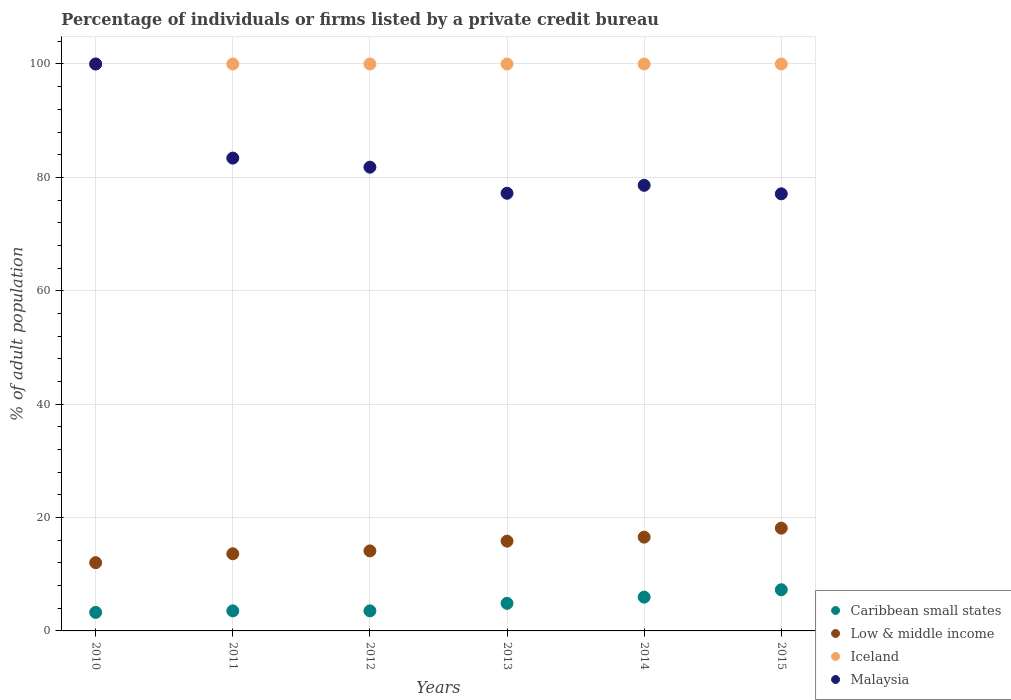How many different coloured dotlines are there?
Your response must be concise. 4. Is the number of dotlines equal to the number of legend labels?
Make the answer very short. Yes. What is the percentage of population listed by a private credit bureau in Iceland in 2011?
Ensure brevity in your answer.  100. Across all years, what is the maximum percentage of population listed by a private credit bureau in Low & middle income?
Your response must be concise. 18.13. Across all years, what is the minimum percentage of population listed by a private credit bureau in Iceland?
Provide a short and direct response. 100. What is the total percentage of population listed by a private credit bureau in Iceland in the graph?
Keep it short and to the point. 600. What is the difference between the percentage of population listed by a private credit bureau in Caribbean small states in 2013 and that in 2015?
Offer a terse response. -2.4. What is the difference between the percentage of population listed by a private credit bureau in Low & middle income in 2013 and the percentage of population listed by a private credit bureau in Caribbean small states in 2014?
Provide a short and direct response. 9.87. What is the average percentage of population listed by a private credit bureau in Malaysia per year?
Ensure brevity in your answer.  83.02. In the year 2015, what is the difference between the percentage of population listed by a private credit bureau in Malaysia and percentage of population listed by a private credit bureau in Low & middle income?
Offer a terse response. 58.97. In how many years, is the percentage of population listed by a private credit bureau in Iceland greater than 68 %?
Provide a succinct answer. 6. What is the ratio of the percentage of population listed by a private credit bureau in Low & middle income in 2010 to that in 2011?
Your response must be concise. 0.88. Is the percentage of population listed by a private credit bureau in Low & middle income in 2012 less than that in 2014?
Your response must be concise. Yes. Is the difference between the percentage of population listed by a private credit bureau in Malaysia in 2010 and 2015 greater than the difference between the percentage of population listed by a private credit bureau in Low & middle income in 2010 and 2015?
Offer a terse response. Yes. What is the difference between the highest and the second highest percentage of population listed by a private credit bureau in Low & middle income?
Ensure brevity in your answer.  1.59. What is the difference between the highest and the lowest percentage of population listed by a private credit bureau in Malaysia?
Your answer should be compact. 22.9. In how many years, is the percentage of population listed by a private credit bureau in Low & middle income greater than the average percentage of population listed by a private credit bureau in Low & middle income taken over all years?
Provide a short and direct response. 3. Is the sum of the percentage of population listed by a private credit bureau in Malaysia in 2010 and 2012 greater than the maximum percentage of population listed by a private credit bureau in Low & middle income across all years?
Your response must be concise. Yes. Is it the case that in every year, the sum of the percentage of population listed by a private credit bureau in Malaysia and percentage of population listed by a private credit bureau in Iceland  is greater than the sum of percentage of population listed by a private credit bureau in Caribbean small states and percentage of population listed by a private credit bureau in Low & middle income?
Your answer should be very brief. Yes. Does the percentage of population listed by a private credit bureau in Caribbean small states monotonically increase over the years?
Provide a succinct answer. No. Is the percentage of population listed by a private credit bureau in Low & middle income strictly greater than the percentage of population listed by a private credit bureau in Malaysia over the years?
Offer a terse response. No. How many dotlines are there?
Provide a short and direct response. 4. What is the difference between two consecutive major ticks on the Y-axis?
Keep it short and to the point. 20. Are the values on the major ticks of Y-axis written in scientific E-notation?
Ensure brevity in your answer.  No. Does the graph contain any zero values?
Ensure brevity in your answer.  No. Where does the legend appear in the graph?
Your response must be concise. Bottom right. How are the legend labels stacked?
Your answer should be compact. Vertical. What is the title of the graph?
Your response must be concise. Percentage of individuals or firms listed by a private credit bureau. Does "Fragile and conflict affected situations" appear as one of the legend labels in the graph?
Provide a succinct answer. No. What is the label or title of the X-axis?
Your answer should be compact. Years. What is the label or title of the Y-axis?
Make the answer very short. % of adult population. What is the % of adult population of Caribbean small states in 2010?
Provide a short and direct response. 3.27. What is the % of adult population in Low & middle income in 2010?
Your answer should be compact. 12.04. What is the % of adult population in Iceland in 2010?
Keep it short and to the point. 100. What is the % of adult population in Malaysia in 2010?
Keep it short and to the point. 100. What is the % of adult population of Caribbean small states in 2011?
Provide a succinct answer. 3.54. What is the % of adult population in Low & middle income in 2011?
Give a very brief answer. 13.61. What is the % of adult population in Iceland in 2011?
Your answer should be very brief. 100. What is the % of adult population of Malaysia in 2011?
Provide a succinct answer. 83.4. What is the % of adult population in Caribbean small states in 2012?
Offer a terse response. 3.54. What is the % of adult population of Low & middle income in 2012?
Make the answer very short. 14.12. What is the % of adult population in Iceland in 2012?
Your answer should be compact. 100. What is the % of adult population in Malaysia in 2012?
Make the answer very short. 81.8. What is the % of adult population in Caribbean small states in 2013?
Offer a very short reply. 4.86. What is the % of adult population of Low & middle income in 2013?
Your answer should be very brief. 15.83. What is the % of adult population in Iceland in 2013?
Provide a succinct answer. 100. What is the % of adult population of Malaysia in 2013?
Offer a terse response. 77.2. What is the % of adult population of Caribbean small states in 2014?
Ensure brevity in your answer.  5.96. What is the % of adult population of Low & middle income in 2014?
Offer a terse response. 16.54. What is the % of adult population of Malaysia in 2014?
Make the answer very short. 78.6. What is the % of adult population in Caribbean small states in 2015?
Your response must be concise. 7.26. What is the % of adult population of Low & middle income in 2015?
Provide a succinct answer. 18.13. What is the % of adult population in Malaysia in 2015?
Give a very brief answer. 77.1. Across all years, what is the maximum % of adult population of Caribbean small states?
Keep it short and to the point. 7.26. Across all years, what is the maximum % of adult population in Low & middle income?
Give a very brief answer. 18.13. Across all years, what is the maximum % of adult population of Iceland?
Ensure brevity in your answer.  100. Across all years, what is the minimum % of adult population in Caribbean small states?
Your answer should be very brief. 3.27. Across all years, what is the minimum % of adult population of Low & middle income?
Your response must be concise. 12.04. Across all years, what is the minimum % of adult population in Malaysia?
Your answer should be compact. 77.1. What is the total % of adult population of Caribbean small states in the graph?
Your response must be concise. 28.43. What is the total % of adult population in Low & middle income in the graph?
Provide a succinct answer. 90.27. What is the total % of adult population in Iceland in the graph?
Your answer should be compact. 600. What is the total % of adult population in Malaysia in the graph?
Provide a succinct answer. 498.1. What is the difference between the % of adult population in Caribbean small states in 2010 and that in 2011?
Ensure brevity in your answer.  -0.27. What is the difference between the % of adult population in Low & middle income in 2010 and that in 2011?
Your answer should be very brief. -1.57. What is the difference between the % of adult population of Iceland in 2010 and that in 2011?
Offer a terse response. 0. What is the difference between the % of adult population in Malaysia in 2010 and that in 2011?
Offer a terse response. 16.6. What is the difference between the % of adult population of Caribbean small states in 2010 and that in 2012?
Provide a succinct answer. -0.27. What is the difference between the % of adult population of Low & middle income in 2010 and that in 2012?
Provide a succinct answer. -2.08. What is the difference between the % of adult population of Malaysia in 2010 and that in 2012?
Provide a succinct answer. 18.2. What is the difference between the % of adult population in Caribbean small states in 2010 and that in 2013?
Your answer should be compact. -1.59. What is the difference between the % of adult population in Low & middle income in 2010 and that in 2013?
Your answer should be compact. -3.8. What is the difference between the % of adult population of Malaysia in 2010 and that in 2013?
Make the answer very short. 22.8. What is the difference between the % of adult population of Caribbean small states in 2010 and that in 2014?
Make the answer very short. -2.69. What is the difference between the % of adult population of Low & middle income in 2010 and that in 2014?
Provide a short and direct response. -4.51. What is the difference between the % of adult population in Malaysia in 2010 and that in 2014?
Ensure brevity in your answer.  21.4. What is the difference between the % of adult population of Caribbean small states in 2010 and that in 2015?
Make the answer very short. -3.99. What is the difference between the % of adult population in Low & middle income in 2010 and that in 2015?
Offer a terse response. -6.09. What is the difference between the % of adult population of Iceland in 2010 and that in 2015?
Offer a very short reply. 0. What is the difference between the % of adult population of Malaysia in 2010 and that in 2015?
Provide a short and direct response. 22.9. What is the difference between the % of adult population of Caribbean small states in 2011 and that in 2012?
Ensure brevity in your answer.  0. What is the difference between the % of adult population of Low & middle income in 2011 and that in 2012?
Your answer should be compact. -0.51. What is the difference between the % of adult population of Caribbean small states in 2011 and that in 2013?
Offer a terse response. -1.32. What is the difference between the % of adult population in Low & middle income in 2011 and that in 2013?
Offer a terse response. -2.23. What is the difference between the % of adult population of Caribbean small states in 2011 and that in 2014?
Offer a terse response. -2.42. What is the difference between the % of adult population of Low & middle income in 2011 and that in 2014?
Make the answer very short. -2.93. What is the difference between the % of adult population in Iceland in 2011 and that in 2014?
Provide a short and direct response. 0. What is the difference between the % of adult population of Malaysia in 2011 and that in 2014?
Offer a terse response. 4.8. What is the difference between the % of adult population of Caribbean small states in 2011 and that in 2015?
Offer a very short reply. -3.72. What is the difference between the % of adult population of Low & middle income in 2011 and that in 2015?
Offer a terse response. -4.52. What is the difference between the % of adult population of Iceland in 2011 and that in 2015?
Give a very brief answer. 0. What is the difference between the % of adult population in Caribbean small states in 2012 and that in 2013?
Ensure brevity in your answer.  -1.32. What is the difference between the % of adult population of Low & middle income in 2012 and that in 2013?
Give a very brief answer. -1.72. What is the difference between the % of adult population of Iceland in 2012 and that in 2013?
Provide a short and direct response. 0. What is the difference between the % of adult population of Malaysia in 2012 and that in 2013?
Ensure brevity in your answer.  4.6. What is the difference between the % of adult population of Caribbean small states in 2012 and that in 2014?
Your answer should be compact. -2.42. What is the difference between the % of adult population of Low & middle income in 2012 and that in 2014?
Ensure brevity in your answer.  -2.43. What is the difference between the % of adult population of Malaysia in 2012 and that in 2014?
Keep it short and to the point. 3.2. What is the difference between the % of adult population of Caribbean small states in 2012 and that in 2015?
Make the answer very short. -3.72. What is the difference between the % of adult population of Low & middle income in 2012 and that in 2015?
Provide a short and direct response. -4.01. What is the difference between the % of adult population in Malaysia in 2012 and that in 2015?
Offer a terse response. 4.7. What is the difference between the % of adult population in Low & middle income in 2013 and that in 2014?
Make the answer very short. -0.71. What is the difference between the % of adult population of Malaysia in 2013 and that in 2014?
Ensure brevity in your answer.  -1.4. What is the difference between the % of adult population of Caribbean small states in 2013 and that in 2015?
Offer a terse response. -2.4. What is the difference between the % of adult population in Low & middle income in 2013 and that in 2015?
Make the answer very short. -2.29. What is the difference between the % of adult population of Iceland in 2013 and that in 2015?
Keep it short and to the point. 0. What is the difference between the % of adult population of Low & middle income in 2014 and that in 2015?
Keep it short and to the point. -1.59. What is the difference between the % of adult population in Iceland in 2014 and that in 2015?
Keep it short and to the point. 0. What is the difference between the % of adult population in Malaysia in 2014 and that in 2015?
Offer a terse response. 1.5. What is the difference between the % of adult population of Caribbean small states in 2010 and the % of adult population of Low & middle income in 2011?
Provide a succinct answer. -10.34. What is the difference between the % of adult population in Caribbean small states in 2010 and the % of adult population in Iceland in 2011?
Provide a succinct answer. -96.73. What is the difference between the % of adult population in Caribbean small states in 2010 and the % of adult population in Malaysia in 2011?
Ensure brevity in your answer.  -80.13. What is the difference between the % of adult population in Low & middle income in 2010 and the % of adult population in Iceland in 2011?
Keep it short and to the point. -87.96. What is the difference between the % of adult population of Low & middle income in 2010 and the % of adult population of Malaysia in 2011?
Keep it short and to the point. -71.36. What is the difference between the % of adult population in Caribbean small states in 2010 and the % of adult population in Low & middle income in 2012?
Provide a succinct answer. -10.85. What is the difference between the % of adult population of Caribbean small states in 2010 and the % of adult population of Iceland in 2012?
Give a very brief answer. -96.73. What is the difference between the % of adult population in Caribbean small states in 2010 and the % of adult population in Malaysia in 2012?
Provide a short and direct response. -78.53. What is the difference between the % of adult population of Low & middle income in 2010 and the % of adult population of Iceland in 2012?
Your answer should be compact. -87.96. What is the difference between the % of adult population in Low & middle income in 2010 and the % of adult population in Malaysia in 2012?
Provide a succinct answer. -69.76. What is the difference between the % of adult population of Iceland in 2010 and the % of adult population of Malaysia in 2012?
Provide a short and direct response. 18.2. What is the difference between the % of adult population in Caribbean small states in 2010 and the % of adult population in Low & middle income in 2013?
Provide a short and direct response. -12.57. What is the difference between the % of adult population in Caribbean small states in 2010 and the % of adult population in Iceland in 2013?
Your response must be concise. -96.73. What is the difference between the % of adult population of Caribbean small states in 2010 and the % of adult population of Malaysia in 2013?
Provide a succinct answer. -73.93. What is the difference between the % of adult population in Low & middle income in 2010 and the % of adult population in Iceland in 2013?
Your answer should be very brief. -87.96. What is the difference between the % of adult population of Low & middle income in 2010 and the % of adult population of Malaysia in 2013?
Keep it short and to the point. -65.16. What is the difference between the % of adult population of Iceland in 2010 and the % of adult population of Malaysia in 2013?
Make the answer very short. 22.8. What is the difference between the % of adult population of Caribbean small states in 2010 and the % of adult population of Low & middle income in 2014?
Your response must be concise. -13.28. What is the difference between the % of adult population in Caribbean small states in 2010 and the % of adult population in Iceland in 2014?
Make the answer very short. -96.73. What is the difference between the % of adult population in Caribbean small states in 2010 and the % of adult population in Malaysia in 2014?
Give a very brief answer. -75.33. What is the difference between the % of adult population of Low & middle income in 2010 and the % of adult population of Iceland in 2014?
Ensure brevity in your answer.  -87.96. What is the difference between the % of adult population in Low & middle income in 2010 and the % of adult population in Malaysia in 2014?
Your answer should be very brief. -66.56. What is the difference between the % of adult population of Iceland in 2010 and the % of adult population of Malaysia in 2014?
Your answer should be compact. 21.4. What is the difference between the % of adult population in Caribbean small states in 2010 and the % of adult population in Low & middle income in 2015?
Your answer should be very brief. -14.86. What is the difference between the % of adult population in Caribbean small states in 2010 and the % of adult population in Iceland in 2015?
Ensure brevity in your answer.  -96.73. What is the difference between the % of adult population in Caribbean small states in 2010 and the % of adult population in Malaysia in 2015?
Offer a terse response. -73.83. What is the difference between the % of adult population in Low & middle income in 2010 and the % of adult population in Iceland in 2015?
Keep it short and to the point. -87.96. What is the difference between the % of adult population of Low & middle income in 2010 and the % of adult population of Malaysia in 2015?
Make the answer very short. -65.06. What is the difference between the % of adult population of Iceland in 2010 and the % of adult population of Malaysia in 2015?
Provide a short and direct response. 22.9. What is the difference between the % of adult population of Caribbean small states in 2011 and the % of adult population of Low & middle income in 2012?
Make the answer very short. -10.58. What is the difference between the % of adult population in Caribbean small states in 2011 and the % of adult population in Iceland in 2012?
Ensure brevity in your answer.  -96.46. What is the difference between the % of adult population of Caribbean small states in 2011 and the % of adult population of Malaysia in 2012?
Your response must be concise. -78.26. What is the difference between the % of adult population in Low & middle income in 2011 and the % of adult population in Iceland in 2012?
Offer a very short reply. -86.39. What is the difference between the % of adult population of Low & middle income in 2011 and the % of adult population of Malaysia in 2012?
Your answer should be compact. -68.19. What is the difference between the % of adult population in Iceland in 2011 and the % of adult population in Malaysia in 2012?
Offer a very short reply. 18.2. What is the difference between the % of adult population of Caribbean small states in 2011 and the % of adult population of Low & middle income in 2013?
Offer a terse response. -12.3. What is the difference between the % of adult population in Caribbean small states in 2011 and the % of adult population in Iceland in 2013?
Your response must be concise. -96.46. What is the difference between the % of adult population of Caribbean small states in 2011 and the % of adult population of Malaysia in 2013?
Your response must be concise. -73.66. What is the difference between the % of adult population of Low & middle income in 2011 and the % of adult population of Iceland in 2013?
Provide a short and direct response. -86.39. What is the difference between the % of adult population in Low & middle income in 2011 and the % of adult population in Malaysia in 2013?
Keep it short and to the point. -63.59. What is the difference between the % of adult population in Iceland in 2011 and the % of adult population in Malaysia in 2013?
Your response must be concise. 22.8. What is the difference between the % of adult population in Caribbean small states in 2011 and the % of adult population in Low & middle income in 2014?
Offer a very short reply. -13. What is the difference between the % of adult population of Caribbean small states in 2011 and the % of adult population of Iceland in 2014?
Your answer should be very brief. -96.46. What is the difference between the % of adult population of Caribbean small states in 2011 and the % of adult population of Malaysia in 2014?
Offer a very short reply. -75.06. What is the difference between the % of adult population of Low & middle income in 2011 and the % of adult population of Iceland in 2014?
Offer a very short reply. -86.39. What is the difference between the % of adult population of Low & middle income in 2011 and the % of adult population of Malaysia in 2014?
Provide a succinct answer. -64.99. What is the difference between the % of adult population of Iceland in 2011 and the % of adult population of Malaysia in 2014?
Your answer should be very brief. 21.4. What is the difference between the % of adult population in Caribbean small states in 2011 and the % of adult population in Low & middle income in 2015?
Your answer should be very brief. -14.59. What is the difference between the % of adult population in Caribbean small states in 2011 and the % of adult population in Iceland in 2015?
Your answer should be compact. -96.46. What is the difference between the % of adult population of Caribbean small states in 2011 and the % of adult population of Malaysia in 2015?
Ensure brevity in your answer.  -73.56. What is the difference between the % of adult population of Low & middle income in 2011 and the % of adult population of Iceland in 2015?
Your answer should be compact. -86.39. What is the difference between the % of adult population in Low & middle income in 2011 and the % of adult population in Malaysia in 2015?
Your answer should be very brief. -63.49. What is the difference between the % of adult population of Iceland in 2011 and the % of adult population of Malaysia in 2015?
Offer a terse response. 22.9. What is the difference between the % of adult population in Caribbean small states in 2012 and the % of adult population in Low & middle income in 2013?
Your answer should be very brief. -12.3. What is the difference between the % of adult population of Caribbean small states in 2012 and the % of adult population of Iceland in 2013?
Your answer should be very brief. -96.46. What is the difference between the % of adult population in Caribbean small states in 2012 and the % of adult population in Malaysia in 2013?
Offer a terse response. -73.66. What is the difference between the % of adult population in Low & middle income in 2012 and the % of adult population in Iceland in 2013?
Offer a terse response. -85.88. What is the difference between the % of adult population in Low & middle income in 2012 and the % of adult population in Malaysia in 2013?
Provide a succinct answer. -63.08. What is the difference between the % of adult population of Iceland in 2012 and the % of adult population of Malaysia in 2013?
Offer a very short reply. 22.8. What is the difference between the % of adult population in Caribbean small states in 2012 and the % of adult population in Low & middle income in 2014?
Provide a short and direct response. -13. What is the difference between the % of adult population of Caribbean small states in 2012 and the % of adult population of Iceland in 2014?
Your answer should be very brief. -96.46. What is the difference between the % of adult population in Caribbean small states in 2012 and the % of adult population in Malaysia in 2014?
Make the answer very short. -75.06. What is the difference between the % of adult population in Low & middle income in 2012 and the % of adult population in Iceland in 2014?
Provide a succinct answer. -85.88. What is the difference between the % of adult population in Low & middle income in 2012 and the % of adult population in Malaysia in 2014?
Ensure brevity in your answer.  -64.48. What is the difference between the % of adult population in Iceland in 2012 and the % of adult population in Malaysia in 2014?
Ensure brevity in your answer.  21.4. What is the difference between the % of adult population of Caribbean small states in 2012 and the % of adult population of Low & middle income in 2015?
Your answer should be compact. -14.59. What is the difference between the % of adult population of Caribbean small states in 2012 and the % of adult population of Iceland in 2015?
Ensure brevity in your answer.  -96.46. What is the difference between the % of adult population of Caribbean small states in 2012 and the % of adult population of Malaysia in 2015?
Ensure brevity in your answer.  -73.56. What is the difference between the % of adult population in Low & middle income in 2012 and the % of adult population in Iceland in 2015?
Keep it short and to the point. -85.88. What is the difference between the % of adult population of Low & middle income in 2012 and the % of adult population of Malaysia in 2015?
Provide a succinct answer. -62.98. What is the difference between the % of adult population of Iceland in 2012 and the % of adult population of Malaysia in 2015?
Your answer should be compact. 22.9. What is the difference between the % of adult population of Caribbean small states in 2013 and the % of adult population of Low & middle income in 2014?
Your answer should be very brief. -11.68. What is the difference between the % of adult population in Caribbean small states in 2013 and the % of adult population in Iceland in 2014?
Keep it short and to the point. -95.14. What is the difference between the % of adult population in Caribbean small states in 2013 and the % of adult population in Malaysia in 2014?
Your answer should be compact. -73.74. What is the difference between the % of adult population of Low & middle income in 2013 and the % of adult population of Iceland in 2014?
Keep it short and to the point. -84.17. What is the difference between the % of adult population of Low & middle income in 2013 and the % of adult population of Malaysia in 2014?
Make the answer very short. -62.77. What is the difference between the % of adult population of Iceland in 2013 and the % of adult population of Malaysia in 2014?
Your response must be concise. 21.4. What is the difference between the % of adult population in Caribbean small states in 2013 and the % of adult population in Low & middle income in 2015?
Provide a succinct answer. -13.27. What is the difference between the % of adult population of Caribbean small states in 2013 and the % of adult population of Iceland in 2015?
Give a very brief answer. -95.14. What is the difference between the % of adult population in Caribbean small states in 2013 and the % of adult population in Malaysia in 2015?
Make the answer very short. -72.24. What is the difference between the % of adult population of Low & middle income in 2013 and the % of adult population of Iceland in 2015?
Your answer should be compact. -84.17. What is the difference between the % of adult population in Low & middle income in 2013 and the % of adult population in Malaysia in 2015?
Give a very brief answer. -61.27. What is the difference between the % of adult population in Iceland in 2013 and the % of adult population in Malaysia in 2015?
Ensure brevity in your answer.  22.9. What is the difference between the % of adult population in Caribbean small states in 2014 and the % of adult population in Low & middle income in 2015?
Keep it short and to the point. -12.17. What is the difference between the % of adult population in Caribbean small states in 2014 and the % of adult population in Iceland in 2015?
Give a very brief answer. -94.04. What is the difference between the % of adult population in Caribbean small states in 2014 and the % of adult population in Malaysia in 2015?
Offer a terse response. -71.14. What is the difference between the % of adult population in Low & middle income in 2014 and the % of adult population in Iceland in 2015?
Offer a very short reply. -83.46. What is the difference between the % of adult population in Low & middle income in 2014 and the % of adult population in Malaysia in 2015?
Keep it short and to the point. -60.56. What is the difference between the % of adult population in Iceland in 2014 and the % of adult population in Malaysia in 2015?
Make the answer very short. 22.9. What is the average % of adult population in Caribbean small states per year?
Provide a short and direct response. 4.74. What is the average % of adult population in Low & middle income per year?
Your answer should be compact. 15.04. What is the average % of adult population in Iceland per year?
Make the answer very short. 100. What is the average % of adult population in Malaysia per year?
Ensure brevity in your answer.  83.02. In the year 2010, what is the difference between the % of adult population in Caribbean small states and % of adult population in Low & middle income?
Ensure brevity in your answer.  -8.77. In the year 2010, what is the difference between the % of adult population of Caribbean small states and % of adult population of Iceland?
Your response must be concise. -96.73. In the year 2010, what is the difference between the % of adult population in Caribbean small states and % of adult population in Malaysia?
Provide a short and direct response. -96.73. In the year 2010, what is the difference between the % of adult population in Low & middle income and % of adult population in Iceland?
Provide a short and direct response. -87.96. In the year 2010, what is the difference between the % of adult population of Low & middle income and % of adult population of Malaysia?
Provide a short and direct response. -87.96. In the year 2011, what is the difference between the % of adult population of Caribbean small states and % of adult population of Low & middle income?
Your answer should be very brief. -10.07. In the year 2011, what is the difference between the % of adult population in Caribbean small states and % of adult population in Iceland?
Your answer should be compact. -96.46. In the year 2011, what is the difference between the % of adult population of Caribbean small states and % of adult population of Malaysia?
Ensure brevity in your answer.  -79.86. In the year 2011, what is the difference between the % of adult population in Low & middle income and % of adult population in Iceland?
Ensure brevity in your answer.  -86.39. In the year 2011, what is the difference between the % of adult population of Low & middle income and % of adult population of Malaysia?
Your answer should be compact. -69.79. In the year 2012, what is the difference between the % of adult population in Caribbean small states and % of adult population in Low & middle income?
Provide a succinct answer. -10.58. In the year 2012, what is the difference between the % of adult population in Caribbean small states and % of adult population in Iceland?
Your response must be concise. -96.46. In the year 2012, what is the difference between the % of adult population of Caribbean small states and % of adult population of Malaysia?
Offer a very short reply. -78.26. In the year 2012, what is the difference between the % of adult population in Low & middle income and % of adult population in Iceland?
Your answer should be very brief. -85.88. In the year 2012, what is the difference between the % of adult population of Low & middle income and % of adult population of Malaysia?
Offer a very short reply. -67.68. In the year 2013, what is the difference between the % of adult population of Caribbean small states and % of adult population of Low & middle income?
Your answer should be compact. -10.97. In the year 2013, what is the difference between the % of adult population of Caribbean small states and % of adult population of Iceland?
Provide a short and direct response. -95.14. In the year 2013, what is the difference between the % of adult population of Caribbean small states and % of adult population of Malaysia?
Offer a terse response. -72.34. In the year 2013, what is the difference between the % of adult population in Low & middle income and % of adult population in Iceland?
Make the answer very short. -84.17. In the year 2013, what is the difference between the % of adult population of Low & middle income and % of adult population of Malaysia?
Provide a short and direct response. -61.37. In the year 2013, what is the difference between the % of adult population in Iceland and % of adult population in Malaysia?
Offer a terse response. 22.8. In the year 2014, what is the difference between the % of adult population of Caribbean small states and % of adult population of Low & middle income?
Your answer should be very brief. -10.58. In the year 2014, what is the difference between the % of adult population of Caribbean small states and % of adult population of Iceland?
Provide a short and direct response. -94.04. In the year 2014, what is the difference between the % of adult population of Caribbean small states and % of adult population of Malaysia?
Provide a succinct answer. -72.64. In the year 2014, what is the difference between the % of adult population of Low & middle income and % of adult population of Iceland?
Provide a succinct answer. -83.46. In the year 2014, what is the difference between the % of adult population of Low & middle income and % of adult population of Malaysia?
Give a very brief answer. -62.06. In the year 2014, what is the difference between the % of adult population of Iceland and % of adult population of Malaysia?
Make the answer very short. 21.4. In the year 2015, what is the difference between the % of adult population in Caribbean small states and % of adult population in Low & middle income?
Provide a short and direct response. -10.87. In the year 2015, what is the difference between the % of adult population in Caribbean small states and % of adult population in Iceland?
Provide a succinct answer. -92.74. In the year 2015, what is the difference between the % of adult population in Caribbean small states and % of adult population in Malaysia?
Provide a succinct answer. -69.84. In the year 2015, what is the difference between the % of adult population in Low & middle income and % of adult population in Iceland?
Your response must be concise. -81.87. In the year 2015, what is the difference between the % of adult population in Low & middle income and % of adult population in Malaysia?
Provide a succinct answer. -58.97. In the year 2015, what is the difference between the % of adult population of Iceland and % of adult population of Malaysia?
Your response must be concise. 22.9. What is the ratio of the % of adult population of Caribbean small states in 2010 to that in 2011?
Make the answer very short. 0.92. What is the ratio of the % of adult population of Low & middle income in 2010 to that in 2011?
Provide a succinct answer. 0.88. What is the ratio of the % of adult population in Iceland in 2010 to that in 2011?
Provide a succinct answer. 1. What is the ratio of the % of adult population in Malaysia in 2010 to that in 2011?
Provide a short and direct response. 1.2. What is the ratio of the % of adult population in Caribbean small states in 2010 to that in 2012?
Your answer should be very brief. 0.92. What is the ratio of the % of adult population in Low & middle income in 2010 to that in 2012?
Give a very brief answer. 0.85. What is the ratio of the % of adult population of Iceland in 2010 to that in 2012?
Keep it short and to the point. 1. What is the ratio of the % of adult population of Malaysia in 2010 to that in 2012?
Offer a very short reply. 1.22. What is the ratio of the % of adult population in Caribbean small states in 2010 to that in 2013?
Give a very brief answer. 0.67. What is the ratio of the % of adult population of Low & middle income in 2010 to that in 2013?
Give a very brief answer. 0.76. What is the ratio of the % of adult population in Iceland in 2010 to that in 2013?
Offer a terse response. 1. What is the ratio of the % of adult population in Malaysia in 2010 to that in 2013?
Make the answer very short. 1.3. What is the ratio of the % of adult population of Caribbean small states in 2010 to that in 2014?
Provide a succinct answer. 0.55. What is the ratio of the % of adult population of Low & middle income in 2010 to that in 2014?
Your answer should be very brief. 0.73. What is the ratio of the % of adult population of Iceland in 2010 to that in 2014?
Your response must be concise. 1. What is the ratio of the % of adult population in Malaysia in 2010 to that in 2014?
Offer a terse response. 1.27. What is the ratio of the % of adult population in Caribbean small states in 2010 to that in 2015?
Keep it short and to the point. 0.45. What is the ratio of the % of adult population of Low & middle income in 2010 to that in 2015?
Offer a terse response. 0.66. What is the ratio of the % of adult population of Malaysia in 2010 to that in 2015?
Give a very brief answer. 1.3. What is the ratio of the % of adult population of Caribbean small states in 2011 to that in 2012?
Your answer should be very brief. 1. What is the ratio of the % of adult population in Low & middle income in 2011 to that in 2012?
Offer a terse response. 0.96. What is the ratio of the % of adult population of Iceland in 2011 to that in 2012?
Keep it short and to the point. 1. What is the ratio of the % of adult population in Malaysia in 2011 to that in 2012?
Offer a very short reply. 1.02. What is the ratio of the % of adult population of Caribbean small states in 2011 to that in 2013?
Give a very brief answer. 0.73. What is the ratio of the % of adult population in Low & middle income in 2011 to that in 2013?
Provide a short and direct response. 0.86. What is the ratio of the % of adult population of Iceland in 2011 to that in 2013?
Give a very brief answer. 1. What is the ratio of the % of adult population of Malaysia in 2011 to that in 2013?
Give a very brief answer. 1.08. What is the ratio of the % of adult population of Caribbean small states in 2011 to that in 2014?
Provide a short and direct response. 0.59. What is the ratio of the % of adult population in Low & middle income in 2011 to that in 2014?
Provide a short and direct response. 0.82. What is the ratio of the % of adult population in Iceland in 2011 to that in 2014?
Offer a terse response. 1. What is the ratio of the % of adult population of Malaysia in 2011 to that in 2014?
Make the answer very short. 1.06. What is the ratio of the % of adult population of Caribbean small states in 2011 to that in 2015?
Your answer should be compact. 0.49. What is the ratio of the % of adult population in Low & middle income in 2011 to that in 2015?
Your response must be concise. 0.75. What is the ratio of the % of adult population in Malaysia in 2011 to that in 2015?
Make the answer very short. 1.08. What is the ratio of the % of adult population of Caribbean small states in 2012 to that in 2013?
Keep it short and to the point. 0.73. What is the ratio of the % of adult population of Low & middle income in 2012 to that in 2013?
Offer a very short reply. 0.89. What is the ratio of the % of adult population in Iceland in 2012 to that in 2013?
Offer a terse response. 1. What is the ratio of the % of adult population in Malaysia in 2012 to that in 2013?
Make the answer very short. 1.06. What is the ratio of the % of adult population of Caribbean small states in 2012 to that in 2014?
Your answer should be compact. 0.59. What is the ratio of the % of adult population in Low & middle income in 2012 to that in 2014?
Offer a terse response. 0.85. What is the ratio of the % of adult population of Iceland in 2012 to that in 2014?
Offer a very short reply. 1. What is the ratio of the % of adult population of Malaysia in 2012 to that in 2014?
Offer a very short reply. 1.04. What is the ratio of the % of adult population in Caribbean small states in 2012 to that in 2015?
Your answer should be compact. 0.49. What is the ratio of the % of adult population in Low & middle income in 2012 to that in 2015?
Provide a succinct answer. 0.78. What is the ratio of the % of adult population of Iceland in 2012 to that in 2015?
Offer a terse response. 1. What is the ratio of the % of adult population of Malaysia in 2012 to that in 2015?
Your answer should be very brief. 1.06. What is the ratio of the % of adult population of Caribbean small states in 2013 to that in 2014?
Provide a short and direct response. 0.82. What is the ratio of the % of adult population of Low & middle income in 2013 to that in 2014?
Make the answer very short. 0.96. What is the ratio of the % of adult population in Iceland in 2013 to that in 2014?
Ensure brevity in your answer.  1. What is the ratio of the % of adult population of Malaysia in 2013 to that in 2014?
Offer a very short reply. 0.98. What is the ratio of the % of adult population in Caribbean small states in 2013 to that in 2015?
Keep it short and to the point. 0.67. What is the ratio of the % of adult population of Low & middle income in 2013 to that in 2015?
Your response must be concise. 0.87. What is the ratio of the % of adult population of Iceland in 2013 to that in 2015?
Keep it short and to the point. 1. What is the ratio of the % of adult population of Caribbean small states in 2014 to that in 2015?
Your answer should be very brief. 0.82. What is the ratio of the % of adult population in Low & middle income in 2014 to that in 2015?
Provide a short and direct response. 0.91. What is the ratio of the % of adult population of Iceland in 2014 to that in 2015?
Your response must be concise. 1. What is the ratio of the % of adult population of Malaysia in 2014 to that in 2015?
Your response must be concise. 1.02. What is the difference between the highest and the second highest % of adult population of Caribbean small states?
Provide a short and direct response. 1.3. What is the difference between the highest and the second highest % of adult population of Low & middle income?
Offer a very short reply. 1.59. What is the difference between the highest and the second highest % of adult population in Malaysia?
Offer a terse response. 16.6. What is the difference between the highest and the lowest % of adult population of Caribbean small states?
Provide a succinct answer. 3.99. What is the difference between the highest and the lowest % of adult population of Low & middle income?
Your response must be concise. 6.09. What is the difference between the highest and the lowest % of adult population of Malaysia?
Provide a succinct answer. 22.9. 